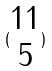<formula> <loc_0><loc_0><loc_500><loc_500>( \begin{matrix} 1 1 \\ 5 \end{matrix} )</formula> 